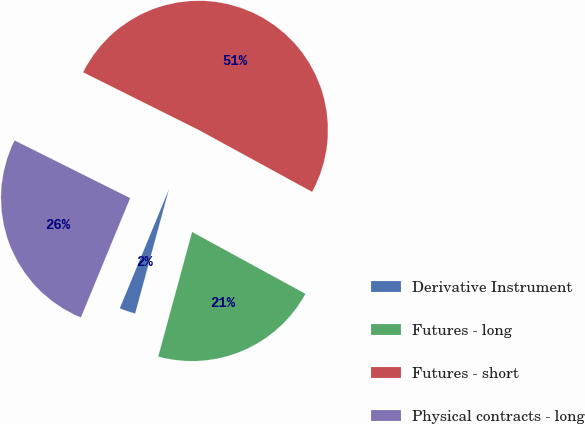Convert chart. <chart><loc_0><loc_0><loc_500><loc_500><pie_chart><fcel>Derivative Instrument<fcel>Futures - long<fcel>Futures - short<fcel>Physical contracts - long<nl><fcel>2.01%<fcel>21.27%<fcel>50.59%<fcel>26.13%<nl></chart> 